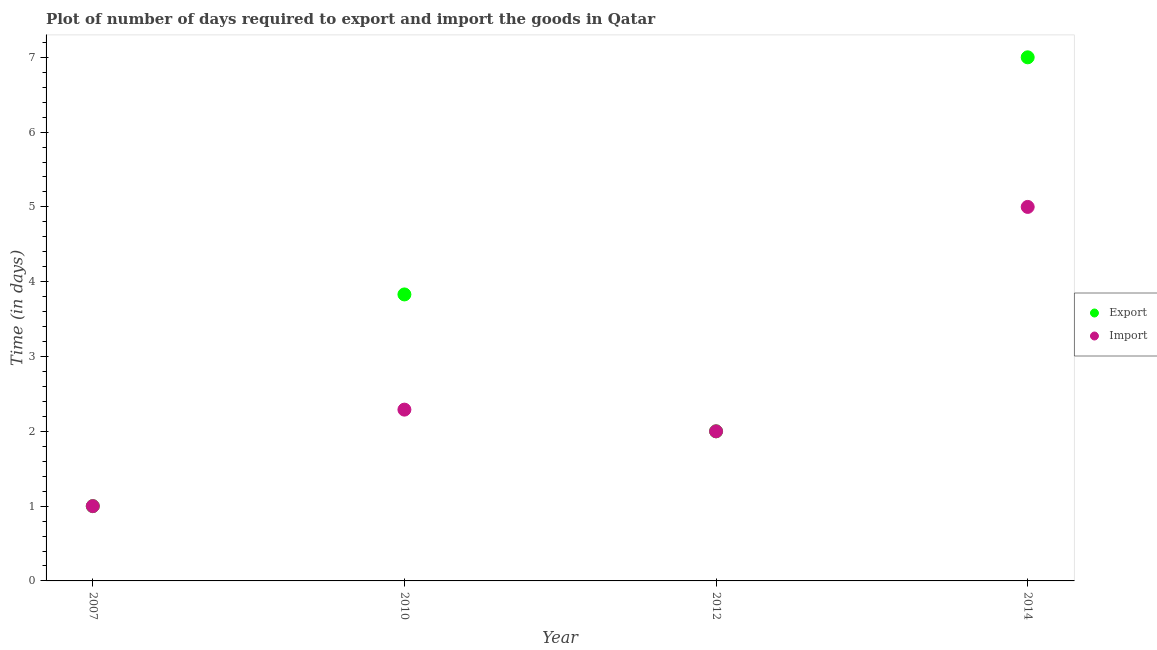What is the time required to import in 2012?
Make the answer very short. 2. What is the total time required to import in the graph?
Provide a short and direct response. 10.29. What is the difference between the time required to import in 2007 and that in 2012?
Keep it short and to the point. -1. What is the difference between the time required to import in 2007 and the time required to export in 2012?
Offer a terse response. -1. What is the average time required to export per year?
Ensure brevity in your answer.  3.46. What is the ratio of the time required to import in 2012 to that in 2014?
Offer a terse response. 0.4. What is the difference between the highest and the second highest time required to export?
Give a very brief answer. 3.17. In how many years, is the time required to import greater than the average time required to import taken over all years?
Provide a short and direct response. 1. Is the sum of the time required to export in 2012 and 2014 greater than the maximum time required to import across all years?
Provide a short and direct response. Yes. How many dotlines are there?
Make the answer very short. 2. What is the difference between two consecutive major ticks on the Y-axis?
Ensure brevity in your answer.  1. Does the graph contain any zero values?
Provide a short and direct response. No. Does the graph contain grids?
Ensure brevity in your answer.  No. Where does the legend appear in the graph?
Your response must be concise. Center right. How many legend labels are there?
Offer a terse response. 2. What is the title of the graph?
Offer a very short reply. Plot of number of days required to export and import the goods in Qatar. What is the label or title of the Y-axis?
Make the answer very short. Time (in days). What is the Time (in days) of Export in 2007?
Offer a very short reply. 1. What is the Time (in days) of Import in 2007?
Make the answer very short. 1. What is the Time (in days) in Export in 2010?
Keep it short and to the point. 3.83. What is the Time (in days) of Import in 2010?
Your answer should be very brief. 2.29. What is the Time (in days) in Export in 2012?
Make the answer very short. 2. What is the Time (in days) in Import in 2012?
Offer a terse response. 2. What is the Time (in days) of Import in 2014?
Offer a terse response. 5. Across all years, what is the maximum Time (in days) in Export?
Give a very brief answer. 7. What is the total Time (in days) in Export in the graph?
Offer a very short reply. 13.83. What is the total Time (in days) in Import in the graph?
Your answer should be compact. 10.29. What is the difference between the Time (in days) of Export in 2007 and that in 2010?
Your response must be concise. -2.83. What is the difference between the Time (in days) of Import in 2007 and that in 2010?
Make the answer very short. -1.29. What is the difference between the Time (in days) in Export in 2007 and that in 2012?
Make the answer very short. -1. What is the difference between the Time (in days) in Export in 2007 and that in 2014?
Offer a very short reply. -6. What is the difference between the Time (in days) of Import in 2007 and that in 2014?
Offer a terse response. -4. What is the difference between the Time (in days) of Export in 2010 and that in 2012?
Offer a very short reply. 1.83. What is the difference between the Time (in days) in Import in 2010 and that in 2012?
Your answer should be compact. 0.29. What is the difference between the Time (in days) in Export in 2010 and that in 2014?
Your answer should be compact. -3.17. What is the difference between the Time (in days) of Import in 2010 and that in 2014?
Ensure brevity in your answer.  -2.71. What is the difference between the Time (in days) of Export in 2012 and that in 2014?
Your answer should be compact. -5. What is the difference between the Time (in days) in Export in 2007 and the Time (in days) in Import in 2010?
Offer a very short reply. -1.29. What is the difference between the Time (in days) in Export in 2007 and the Time (in days) in Import in 2012?
Your answer should be compact. -1. What is the difference between the Time (in days) in Export in 2010 and the Time (in days) in Import in 2012?
Offer a terse response. 1.83. What is the difference between the Time (in days) of Export in 2010 and the Time (in days) of Import in 2014?
Your answer should be compact. -1.17. What is the difference between the Time (in days) of Export in 2012 and the Time (in days) of Import in 2014?
Give a very brief answer. -3. What is the average Time (in days) in Export per year?
Your answer should be very brief. 3.46. What is the average Time (in days) in Import per year?
Your answer should be compact. 2.57. In the year 2010, what is the difference between the Time (in days) of Export and Time (in days) of Import?
Your answer should be very brief. 1.54. In the year 2012, what is the difference between the Time (in days) of Export and Time (in days) of Import?
Your answer should be very brief. 0. What is the ratio of the Time (in days) in Export in 2007 to that in 2010?
Your answer should be compact. 0.26. What is the ratio of the Time (in days) of Import in 2007 to that in 2010?
Make the answer very short. 0.44. What is the ratio of the Time (in days) in Export in 2007 to that in 2014?
Your response must be concise. 0.14. What is the ratio of the Time (in days) of Export in 2010 to that in 2012?
Ensure brevity in your answer.  1.92. What is the ratio of the Time (in days) of Import in 2010 to that in 2012?
Offer a very short reply. 1.15. What is the ratio of the Time (in days) in Export in 2010 to that in 2014?
Your answer should be compact. 0.55. What is the ratio of the Time (in days) of Import in 2010 to that in 2014?
Your answer should be very brief. 0.46. What is the ratio of the Time (in days) of Export in 2012 to that in 2014?
Ensure brevity in your answer.  0.29. What is the difference between the highest and the second highest Time (in days) of Export?
Make the answer very short. 3.17. What is the difference between the highest and the second highest Time (in days) in Import?
Provide a short and direct response. 2.71. 